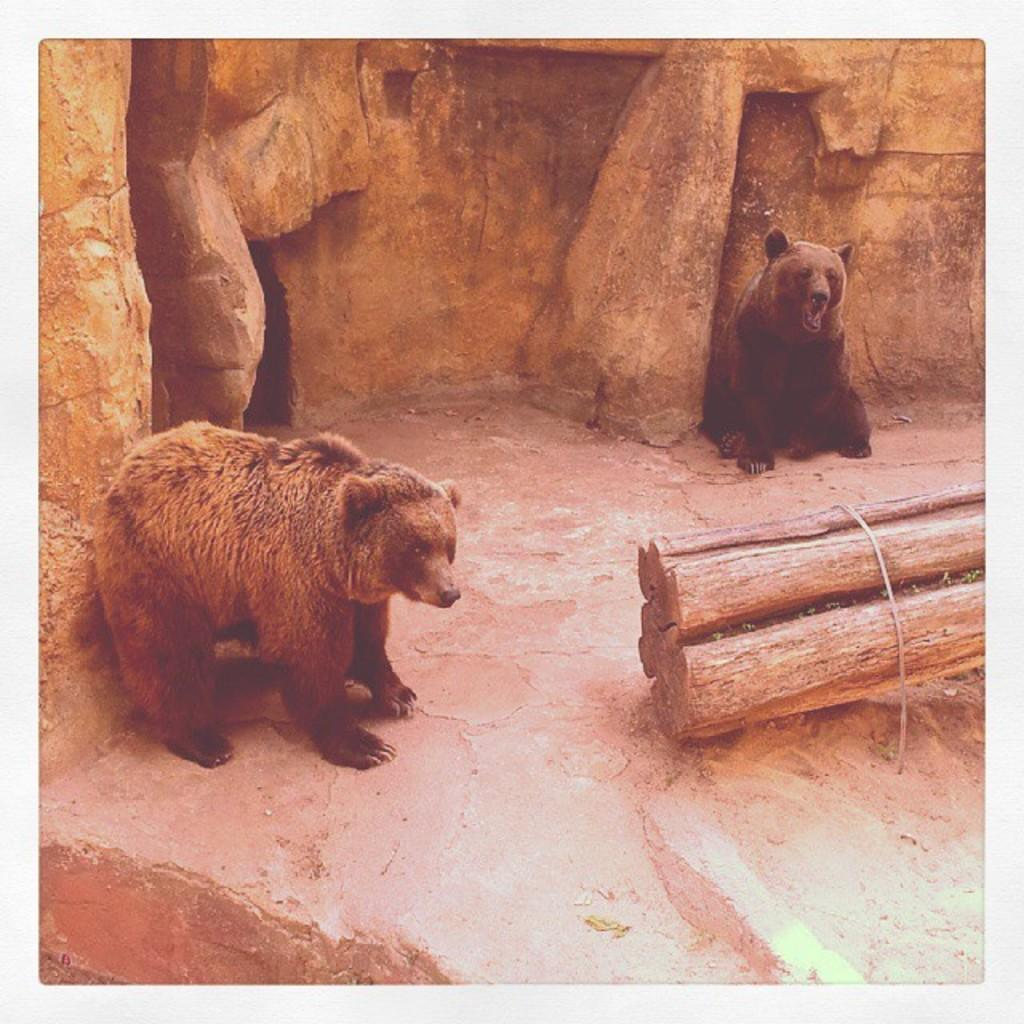How many grizzly bears are in the image? There are two grizzly bears in the image. What objects are in front of the grizzly bears? There are wooden logs and a rope in front of the grizzly bears. What is behind the grizzly bears? There is a wall behind the grizzly bears. What type of fiction is the grizzly bears reading in the image? There is no indication in the image that the grizzly bears are reading any fiction, as they are wild animals and do not read. 